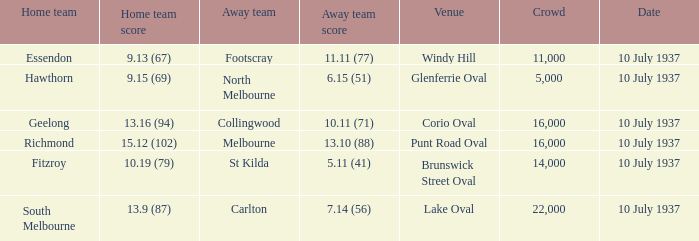What was the lowest Crowd during the Away Team Score of 10.11 (71)? 16000.0. 